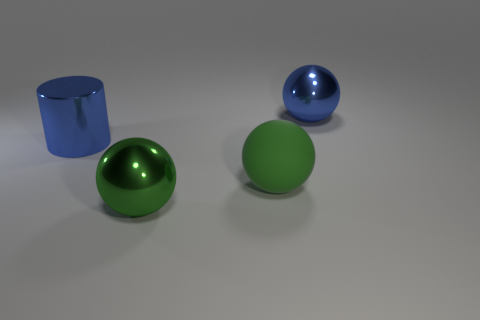What is the material of the big cylinder?
Provide a short and direct response. Metal. Do the big cylinder and the sphere that is on the left side of the large green matte object have the same color?
Your response must be concise. No. Is there anything else that has the same size as the metal cylinder?
Give a very brief answer. Yes. What size is the shiny object that is both left of the green rubber ball and behind the large green shiny object?
Make the answer very short. Large. There is a big blue thing that is made of the same material as the blue cylinder; what is its shape?
Provide a short and direct response. Sphere. Do the large cylinder and the blue thing that is to the right of the blue metallic cylinder have the same material?
Give a very brief answer. Yes. Are there any blue spheres behind the big thing that is in front of the big green rubber object?
Offer a very short reply. Yes. There is another green thing that is the same shape as the green rubber object; what is it made of?
Make the answer very short. Metal. There is a large sphere that is to the right of the green rubber thing; how many balls are to the left of it?
Your answer should be very brief. 2. Is there any other thing that is the same color as the large shiny cylinder?
Give a very brief answer. Yes. 